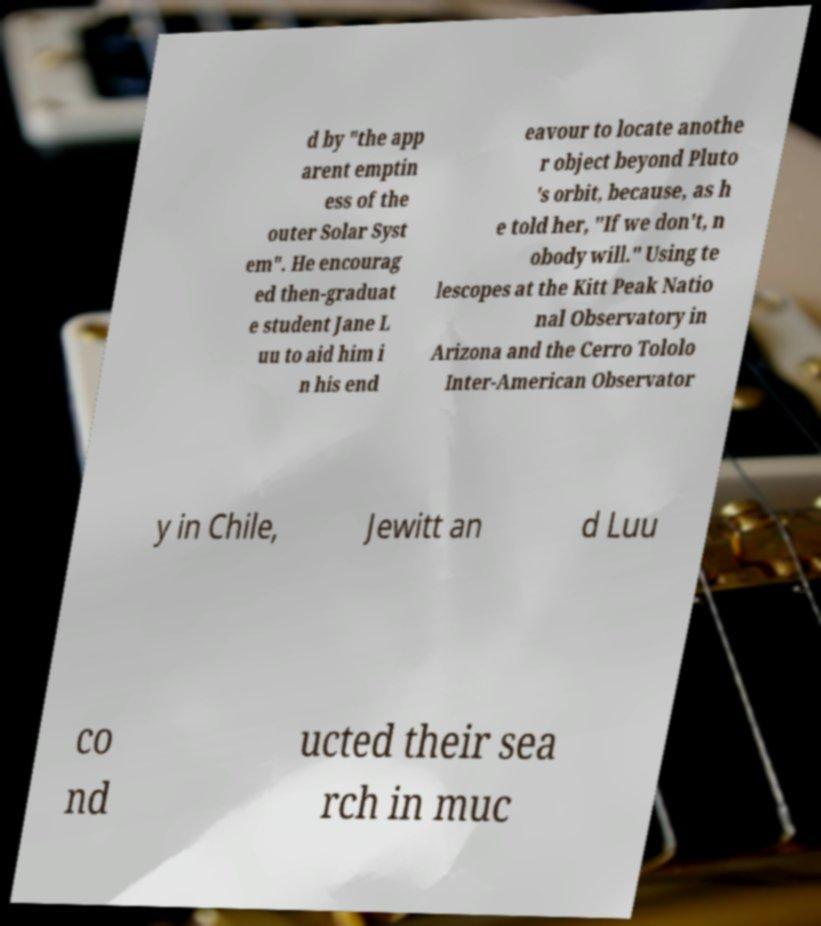Can you read and provide the text displayed in the image?This photo seems to have some interesting text. Can you extract and type it out for me? d by "the app arent emptin ess of the outer Solar Syst em". He encourag ed then-graduat e student Jane L uu to aid him i n his end eavour to locate anothe r object beyond Pluto 's orbit, because, as h e told her, "If we don't, n obody will." Using te lescopes at the Kitt Peak Natio nal Observatory in Arizona and the Cerro Tololo Inter-American Observator y in Chile, Jewitt an d Luu co nd ucted their sea rch in muc 